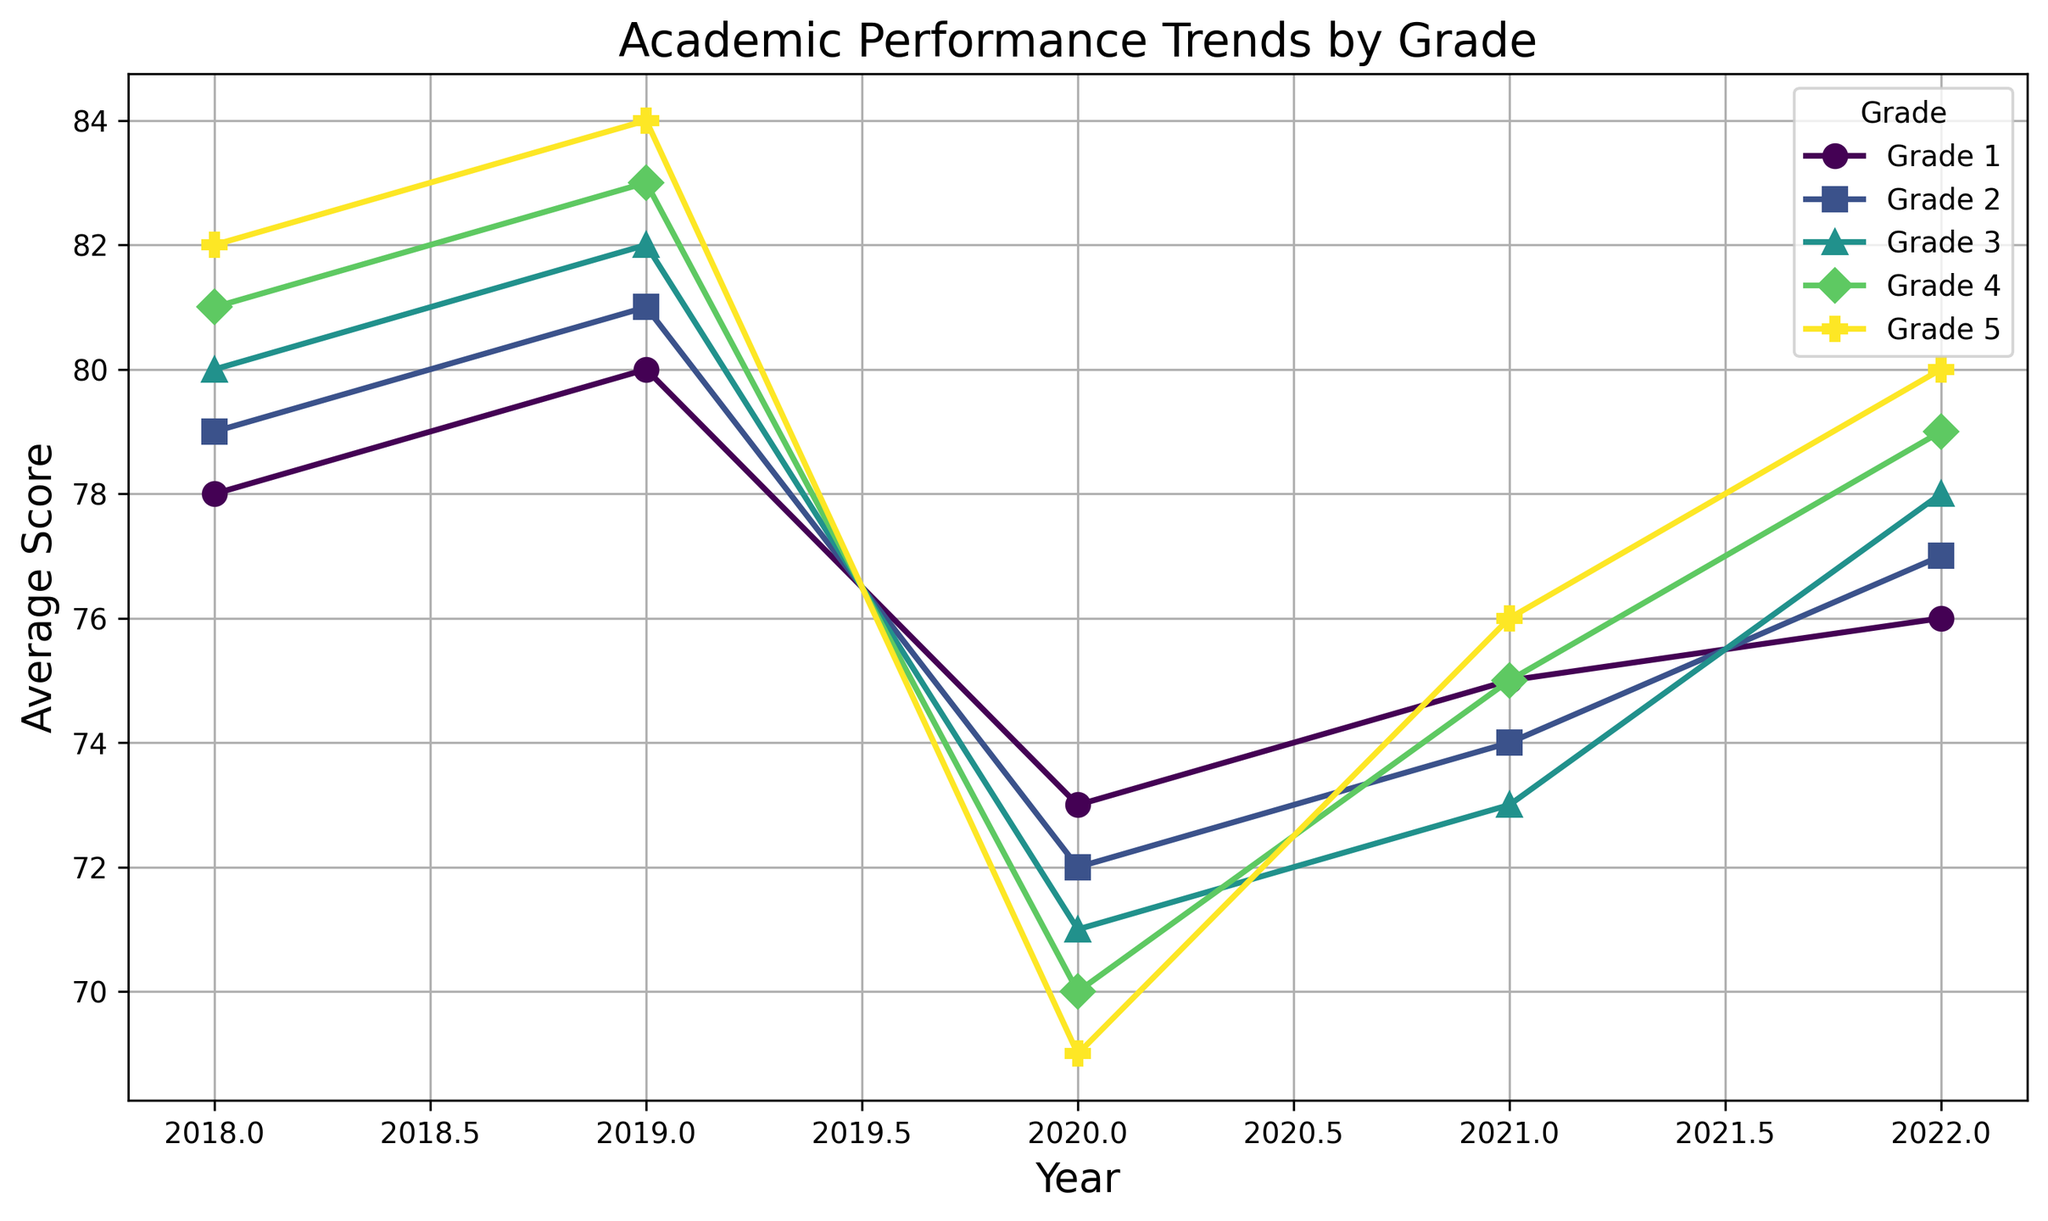what is the overall trend in average scores for Grade 1 from 2018 to 2022? The line plot shows the data points for Grade 1 from 2018 to 2022. Begin at 78 in 2018, increase to 80 in 2019, decrease to 73 in 2020, rise to 75 in 2021, and stabilize at 76 in 2022.
Answer: Decreasing Which grade experienced the steepest decline in average score from 2019 to 2020? By comparing the slope of the lines between 2019 and 2020 for each grade, the biggest drop is visible for Grade 5, which decreases from 84 to 69.
Answer: Grade 5 What is the average performance score for all grades in 2021? Add the average score of each grade in 2021 and then divide by the number of grades: (Grade 1: 75 + Grade 2: 74 + Grade 3: 73 + Grade 4: 75 + Grade 5: 76) / 5 = (75+74+73+75+76)/5 = 373/5 = 74.6
Answer: 74.6 Which grades showed improvement in average scores from 2021 to 2022? By looking at the change in scores from 2021 to 2022, Grades 2 (74 to 77), 3 (73 to 78), 4 (75 to 79), and 5 (76 to 80) all show improvements.
Answer: Grades 2, 3, 4, 5 Is the average score of Grade 3 higher in 2019 or 2022? By comparing the average scores, Grade 3 has 82 in 2019 and 78 in 2022.
Answer: 2019 Comparing Grade 1 and Grade 4, which one had a higher average score in 2020? From the data points in 2020, Grade 1 has a score of 73 whereas Grade 4 has a score of 70.
Answer: Grade 1 Which grade had the highest average score in 2022 and what was the score? By identifying the highest point among the grades in 2022, Grade 5 recorded the top score at 80.
Answer: Grade 5, 80 Between 2018 and 2022, which grade exhibited the least variation in average scores and what is the score range? Grade 1 has scores of 78, 80, 73, 75, and 76. The range is 80 - 73 = 7. Grade 2: range is 81 - 72 = 9. Grade 3: 82 - 71 = 11. Grade 4: 83 - 70 = 13. Grade 5: 84 - 69 = 15. Grade 1 has the least variation of 7 points.
Answer: Grade 1, 7 points How many grades have an average score equal to 75 at any point from 2018 to 2022? Grade 1 in 2021, and Grade 4 in 2021 both have average scores of 75.
Answer: 2 